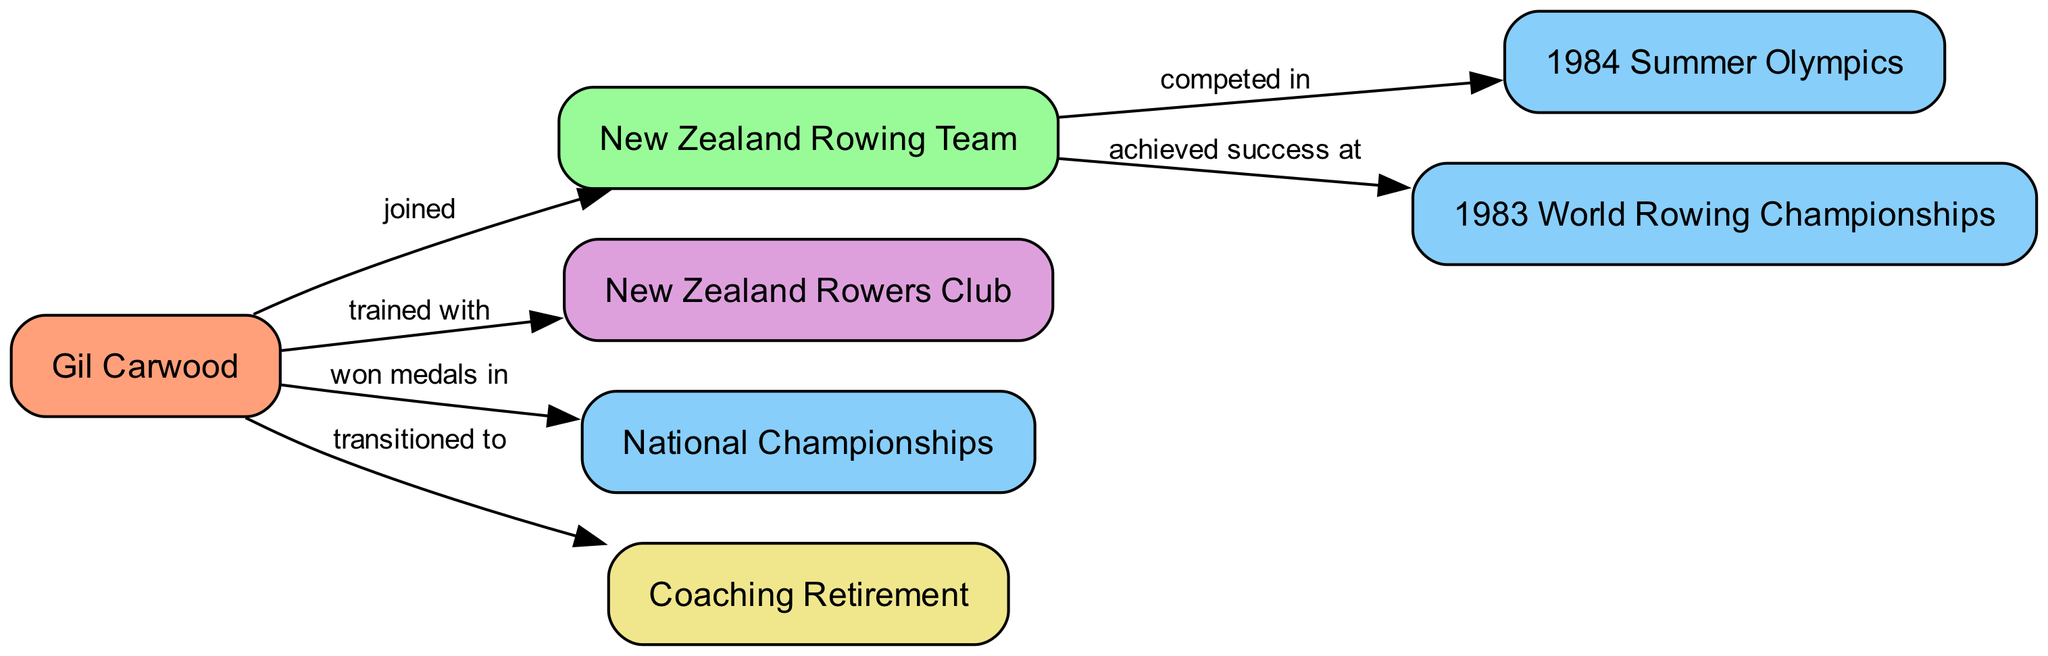What athlete is featured in the diagram? The diagram includes the node labeled "Gil Carwood," which identifies the featured athlete in this career progression.
Answer: Gil Carwood How many events are represented in the diagram? By counting the nodes labeled as "Event," we see there are three events: "1984 Summer Olympics," "1983 World Rowing Championships," and "National Championships."
Answer: 3 What team did Gil Carwood join? The edge from "Gil Carwood" to "New Zealand Rowing Team" indicates that he joined this particular team, making it clear who he represented.
Answer: New Zealand Rowing Team What milestone did Gil Carwood reach related to his coaching career? The edge from "Gil Carwood" to "Coaching Retirement" shows that he transitioned to retirement, marking an important milestone in his career.
Answer: Coaching Retirement In which event did the New Zealand Rowing Team compete? The directed edge from "NZ_Rowing_Team" to "1984 Summer Olympics" specifies that the team competed in this event, making it a direct connection of their involvement.
Answer: 1984 Summer Olympics What club did Gil Carwood train with before his Olympic participation? The edge from "Gil Carwood" to "New Zealand Rowers Club" indicates his training association with this club, thus revealing where he prepared for his competitions.
Answer: New Zealand Rowers Club Which championships did Gil Carwood win medals in? The edge from "Gil Carwood" to "National Championships" shows that he achieved medals in these championships, providing a clear connection to his accolades.
Answer: National Championships What success did the New Zealand Rowing Team achieve in 1983? The edge from "NZ_Rowing_Team" to "World Champs_1983" states that the team achieved success at this event, indicating their accomplishments that year.
Answer: achieved success at How many nodes represent clubs in the diagram? There is only one node labeled as "Club," which is "New Zealand Rowers Club," leading us to conclude how many clubs are represented.
Answer: 1 What was Gil Carwood’s progression to retirement? The pathway shown in the diagram, starting from "Gil Carwood" to "Coaching Retirement," illustrates his transition into retirement after his athletic career.
Answer: transitioned to 